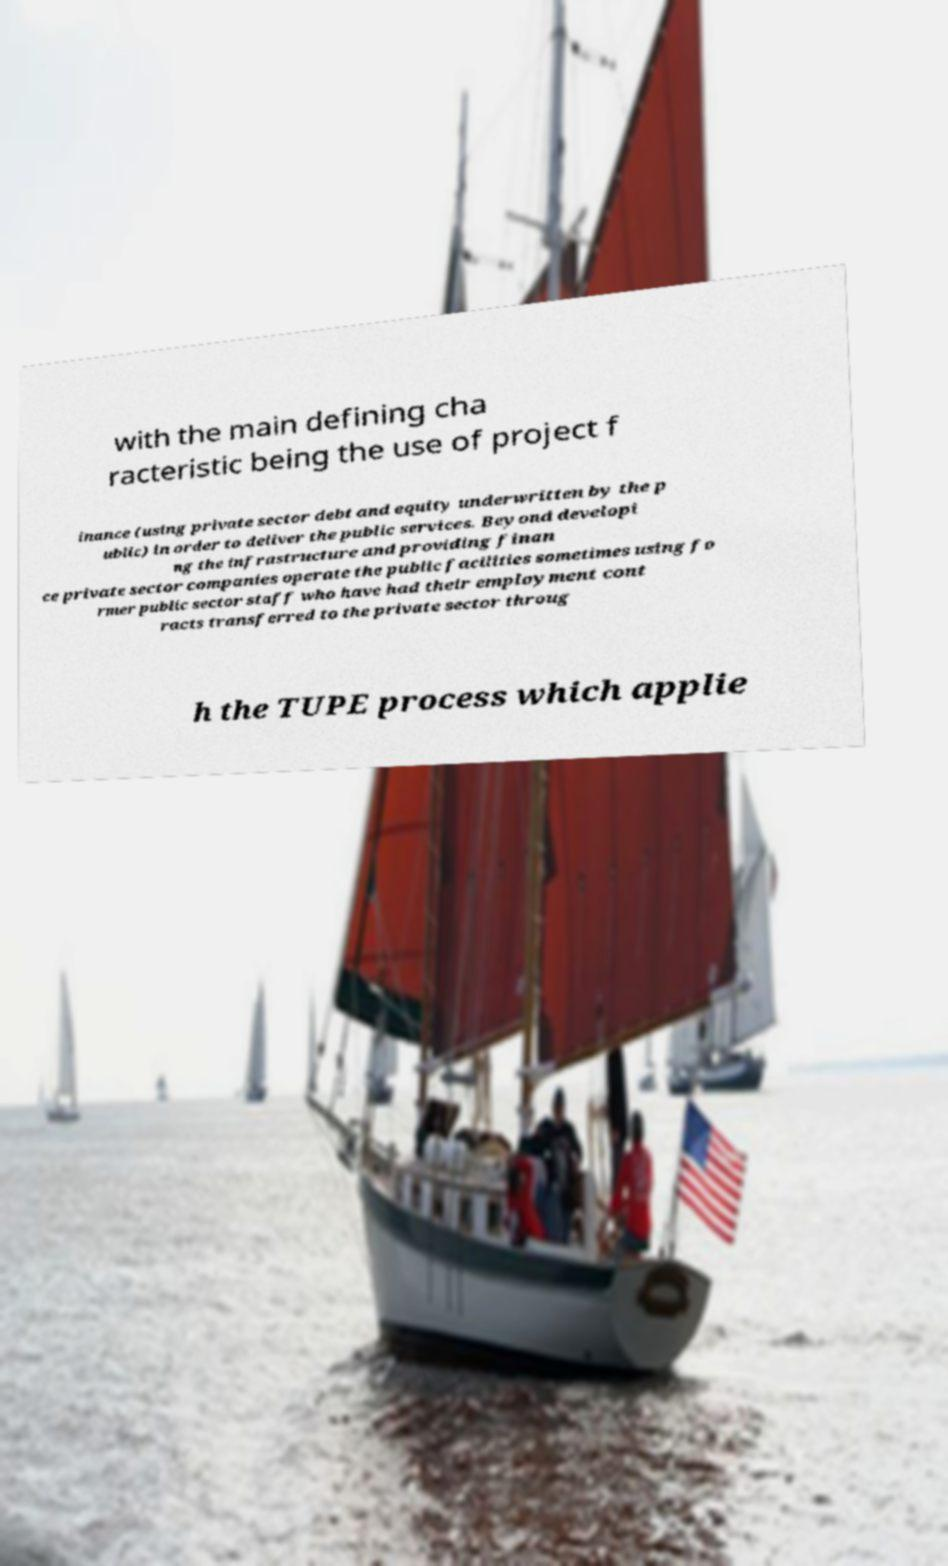Can you accurately transcribe the text from the provided image for me? with the main defining cha racteristic being the use of project f inance (using private sector debt and equity underwritten by the p ublic) in order to deliver the public services. Beyond developi ng the infrastructure and providing finan ce private sector companies operate the public facilities sometimes using fo rmer public sector staff who have had their employment cont racts transferred to the private sector throug h the TUPE process which applie 